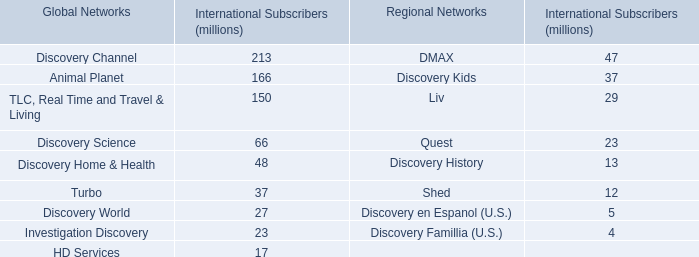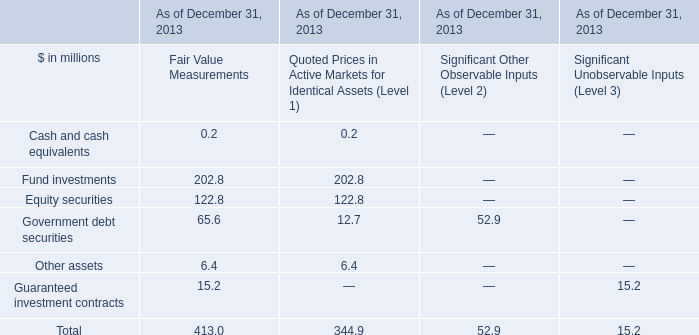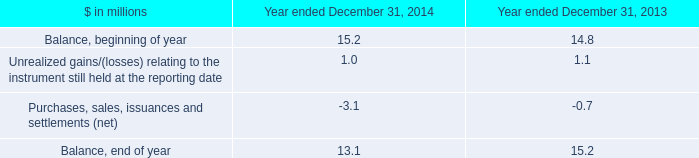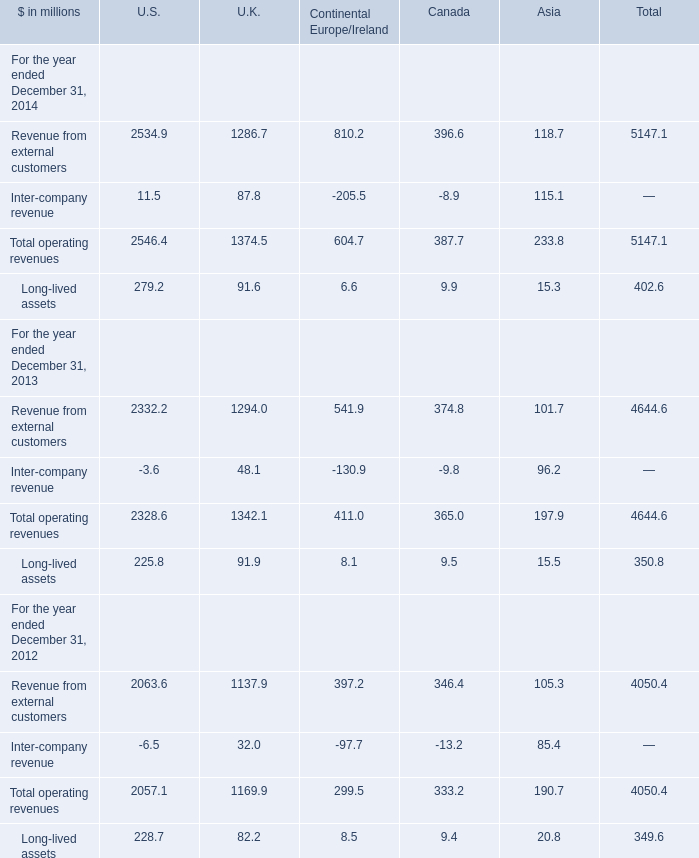What is the sum of the operating revenues of Asia in the years where Long-lived assets of Asia is greater than 20? (in million) 
Computations: (105.3 + 85.4)
Answer: 190.7. 